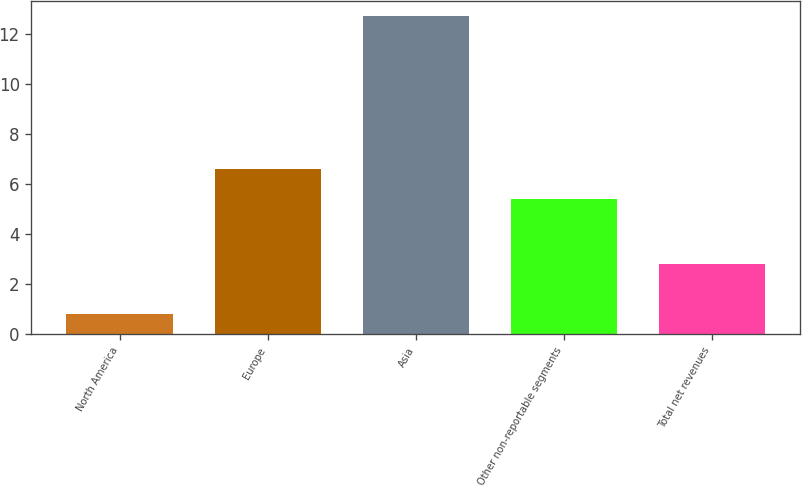Convert chart to OTSL. <chart><loc_0><loc_0><loc_500><loc_500><bar_chart><fcel>North America<fcel>Europe<fcel>Asia<fcel>Other non-reportable segments<fcel>Total net revenues<nl><fcel>0.8<fcel>6.59<fcel>12.7<fcel>5.4<fcel>2.8<nl></chart> 